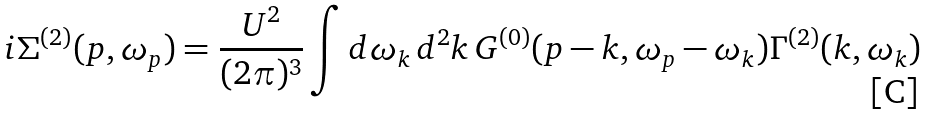<formula> <loc_0><loc_0><loc_500><loc_500>i \Sigma ^ { ( 2 ) } ( { p } , \omega _ { p } ) = \frac { U ^ { 2 } } { ( 2 \pi ) ^ { 3 } } \int d \omega _ { k } \, d ^ { 2 } k \, G ^ { ( 0 ) } ( { p } - { k } , \omega _ { p } - \omega _ { k } ) \Gamma ^ { ( 2 ) } ( { k } , \omega _ { k } )</formula> 